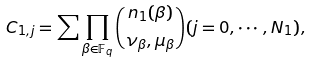<formula> <loc_0><loc_0><loc_500><loc_500>C _ { 1 , j } = \sum \prod _ { \beta \in \mathbb { F } _ { q } } { \binom { n _ { 1 } ( \beta ) } { \nu _ { \beta } , \mu _ { \beta } } } ( j = 0 , \cdots , N _ { 1 } ) ,</formula> 